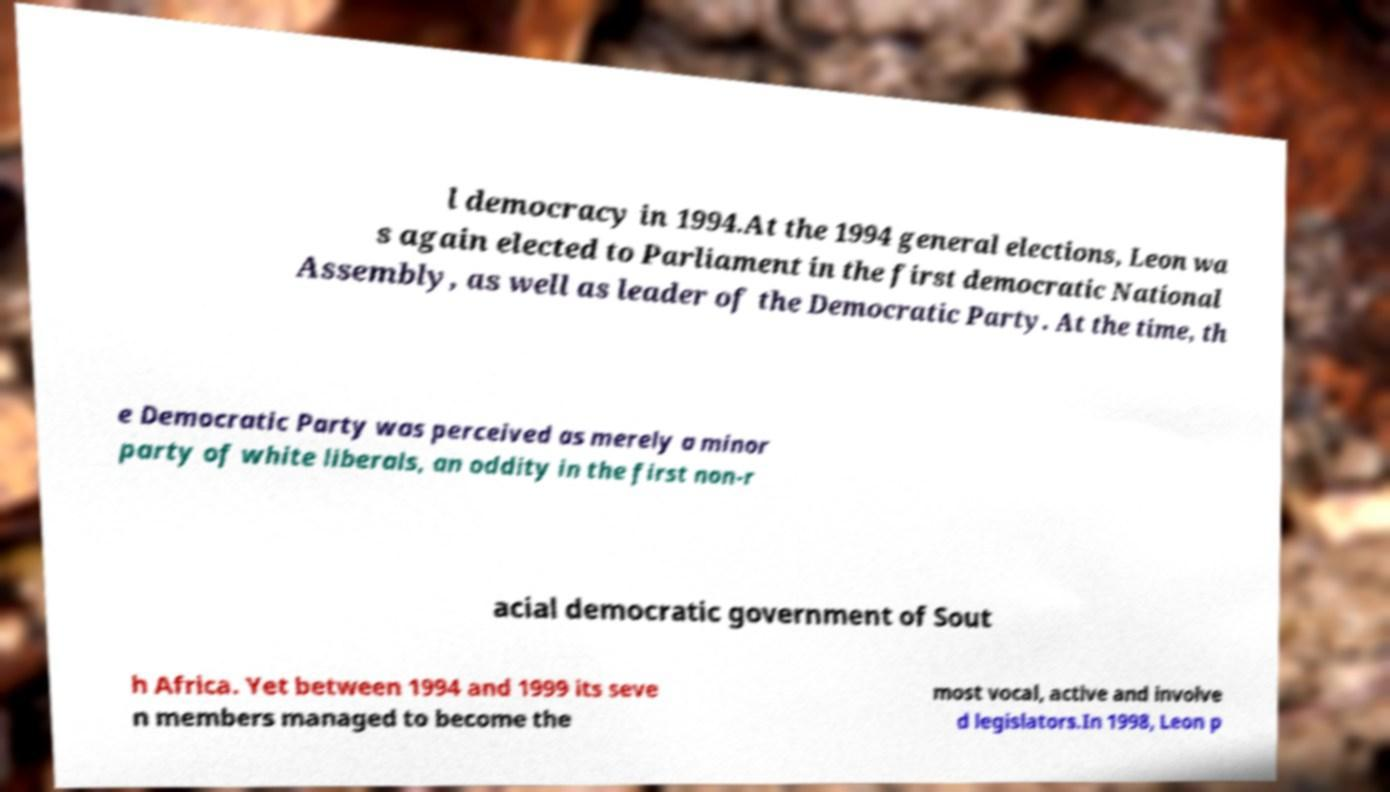Could you assist in decoding the text presented in this image and type it out clearly? l democracy in 1994.At the 1994 general elections, Leon wa s again elected to Parliament in the first democratic National Assembly, as well as leader of the Democratic Party. At the time, th e Democratic Party was perceived as merely a minor party of white liberals, an oddity in the first non-r acial democratic government of Sout h Africa. Yet between 1994 and 1999 its seve n members managed to become the most vocal, active and involve d legislators.In 1998, Leon p 